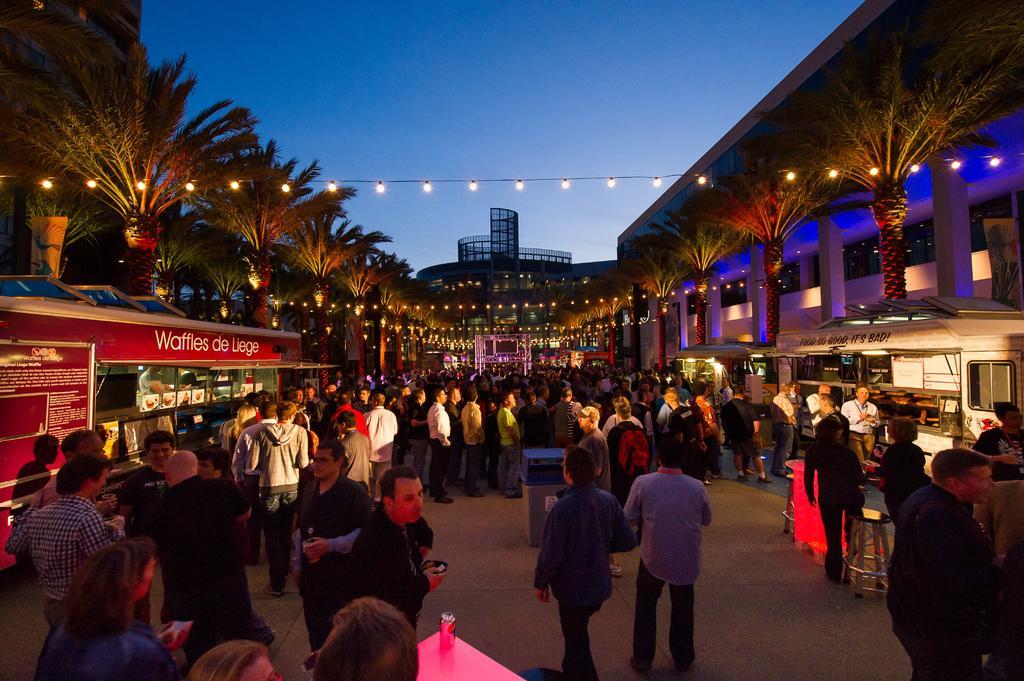How would you summarize this image in a sentence or two? In this picture i can see group of people are standing on the ground. In the background i can see buildings, trees, lights on wire and sky. 